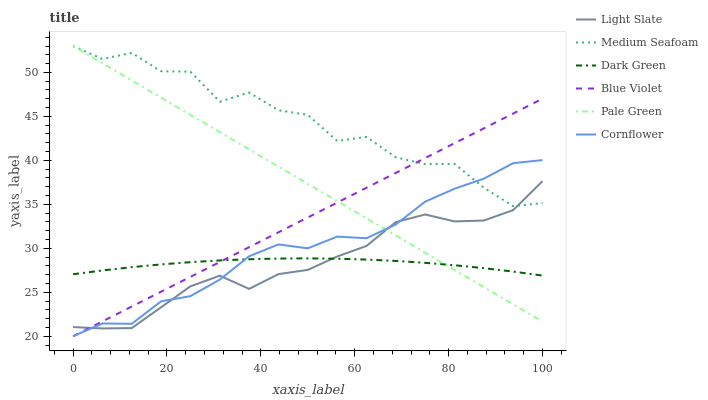Does Dark Green have the minimum area under the curve?
Answer yes or no. Yes. Does Medium Seafoam have the maximum area under the curve?
Answer yes or no. Yes. Does Light Slate have the minimum area under the curve?
Answer yes or no. No. Does Light Slate have the maximum area under the curve?
Answer yes or no. No. Is Blue Violet the smoothest?
Answer yes or no. Yes. Is Medium Seafoam the roughest?
Answer yes or no. Yes. Is Light Slate the smoothest?
Answer yes or no. No. Is Light Slate the roughest?
Answer yes or no. No. Does Light Slate have the lowest value?
Answer yes or no. No. Does Light Slate have the highest value?
Answer yes or no. No. Is Dark Green less than Medium Seafoam?
Answer yes or no. Yes. Is Medium Seafoam greater than Dark Green?
Answer yes or no. Yes. Does Dark Green intersect Medium Seafoam?
Answer yes or no. No. 